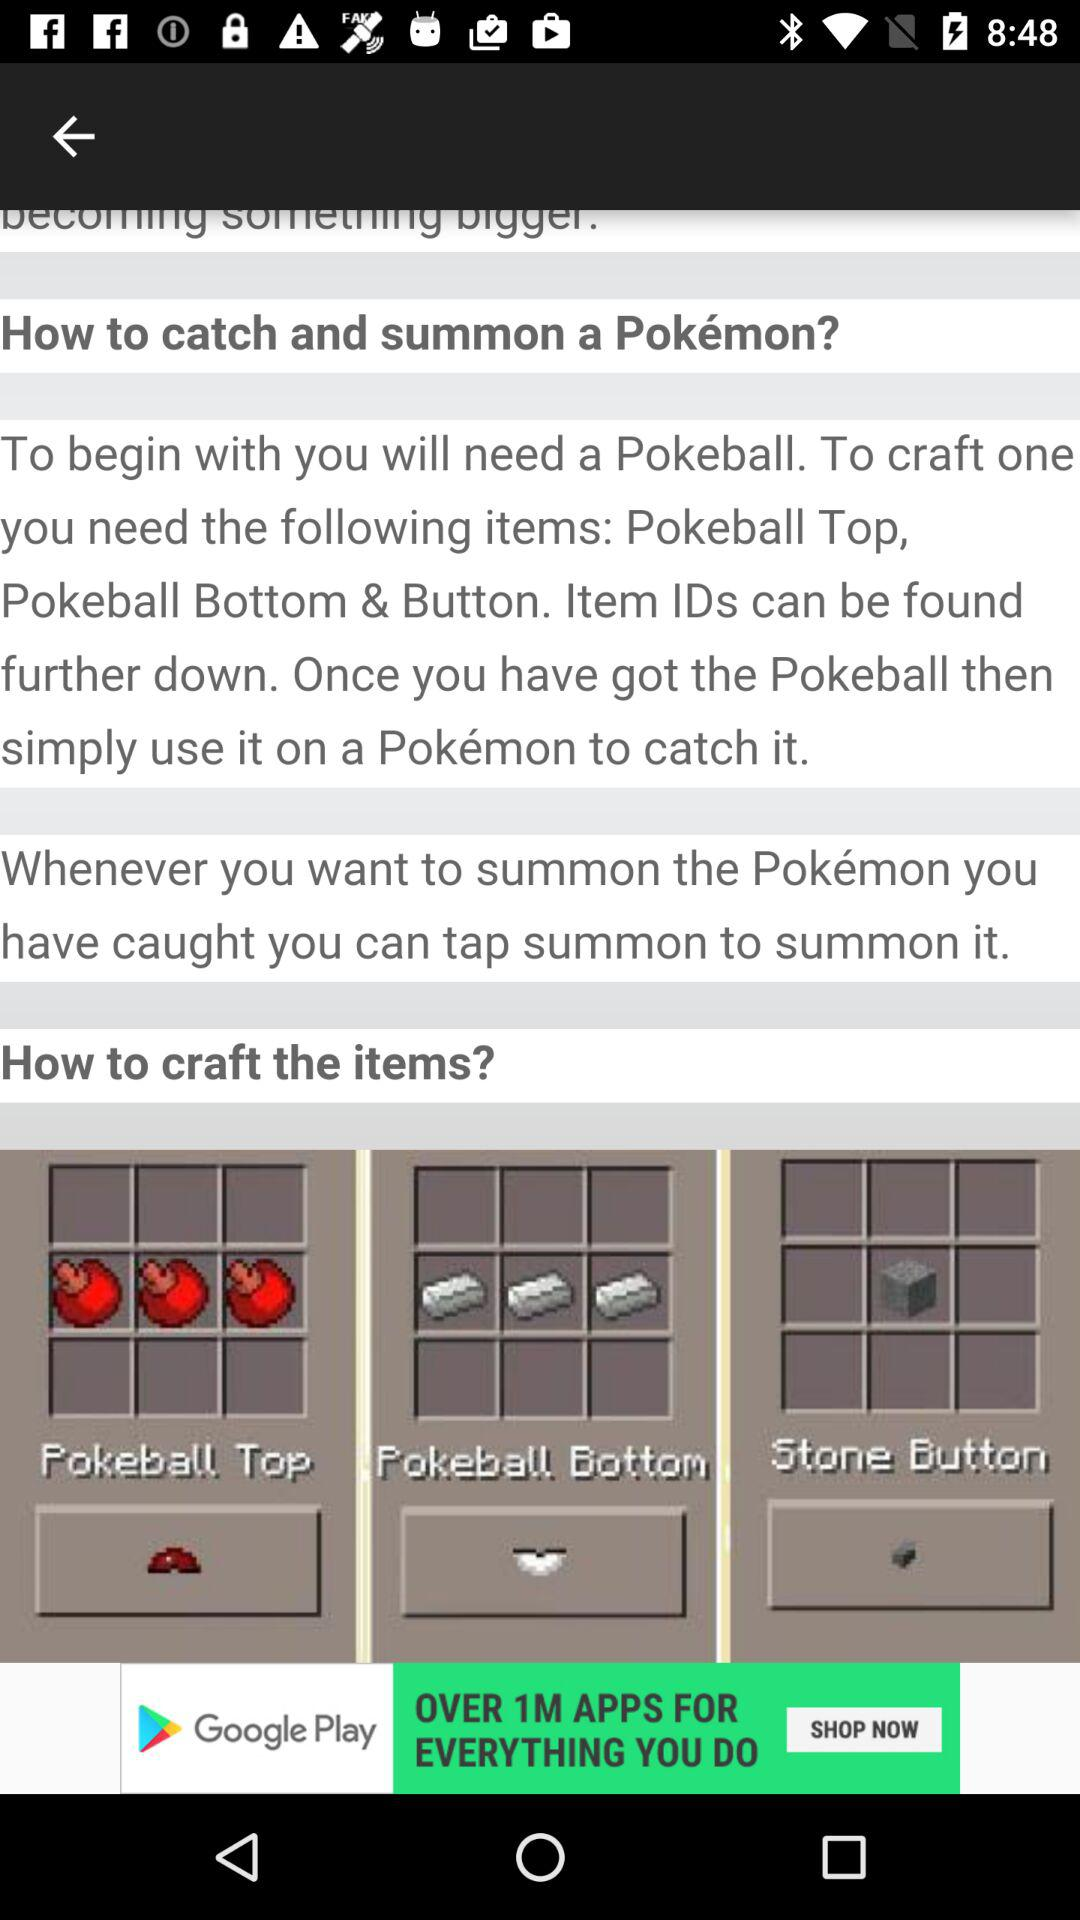How many items are required to craft a Pokeball?
Answer the question using a single word or phrase. 3 